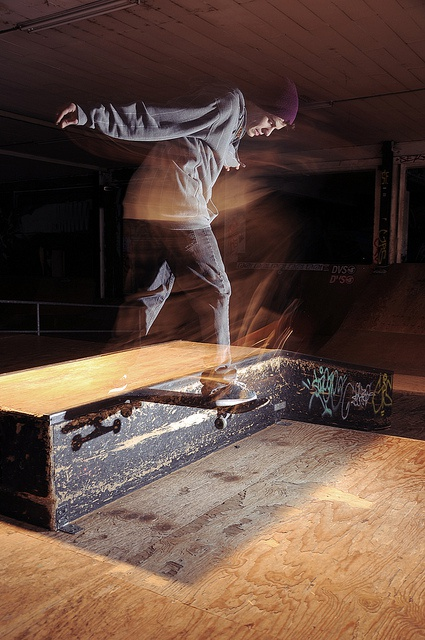Describe the objects in this image and their specific colors. I can see people in black, maroon, darkgray, and gray tones and skateboard in black, maroon, gray, and lightgray tones in this image. 